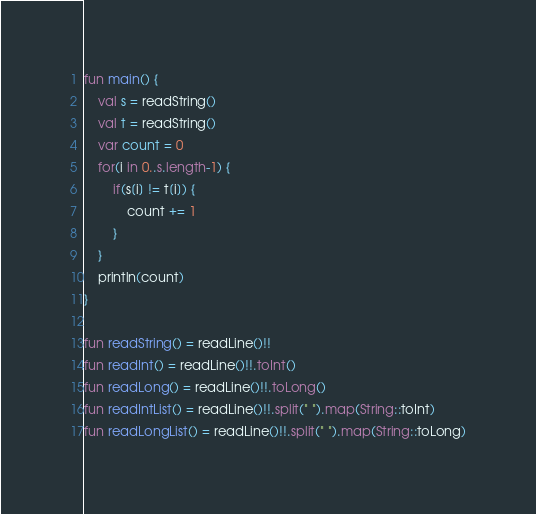Convert code to text. <code><loc_0><loc_0><loc_500><loc_500><_Kotlin_>fun main() {
    val s = readString()
    val t = readString()
    var count = 0
    for(i in 0..s.length-1) {
        if(s[i] != t[i]) {
            count += 1
        }
    }
    println(count)
}

fun readString() = readLine()!!
fun readInt() = readLine()!!.toInt()
fun readLong() = readLine()!!.toLong()
fun readIntList() = readLine()!!.split(" ").map(String::toInt)
fun readLongList() = readLine()!!.split(" ").map(String::toLong)</code> 